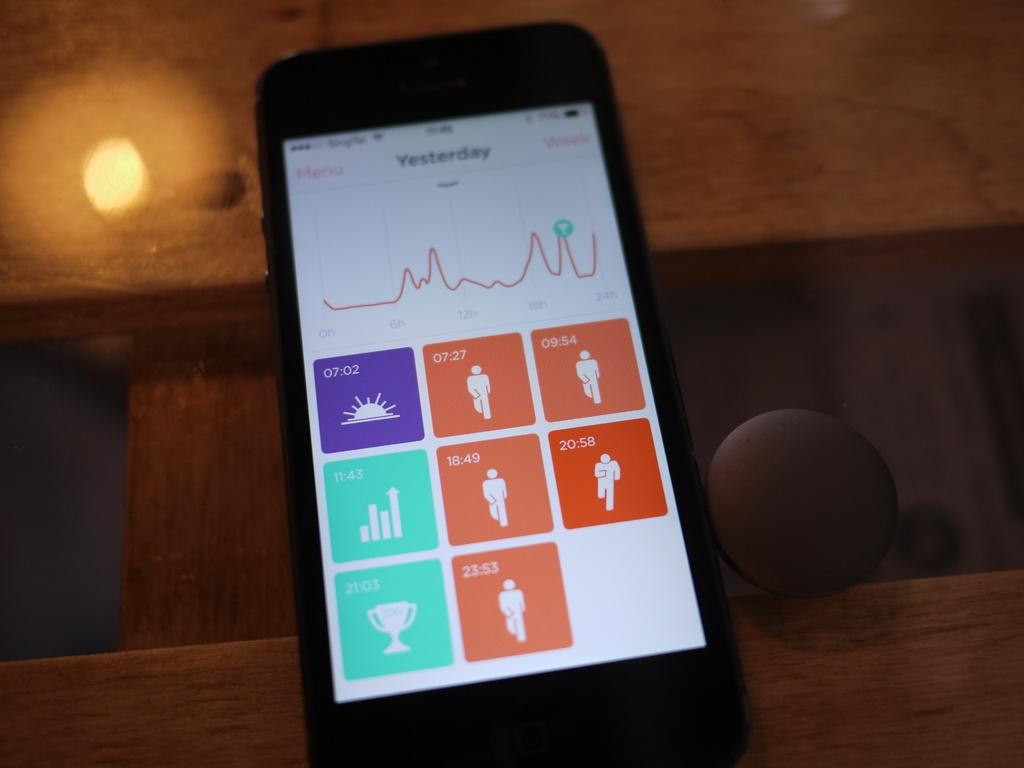Provide a one-sentence caption for the provided image. A smartphone showing yesterday's fitness progress menu with connected to wifi. 